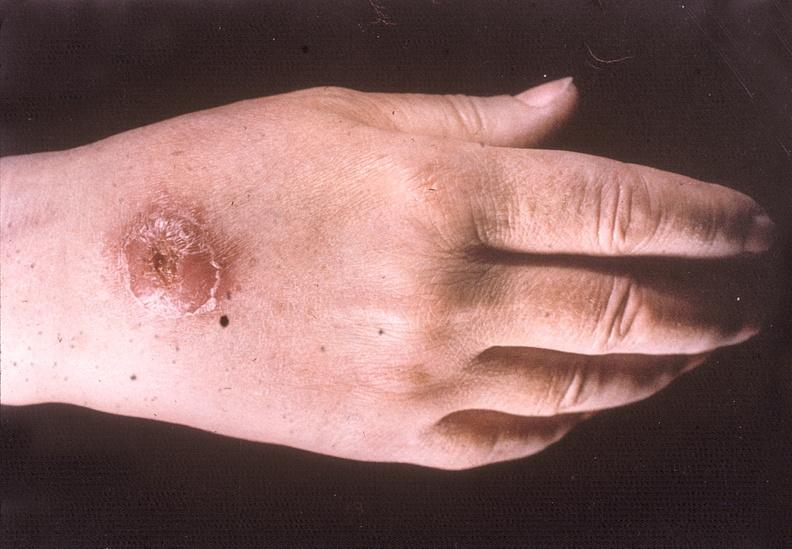re extremities present?
Answer the question using a single word or phrase. Yes 